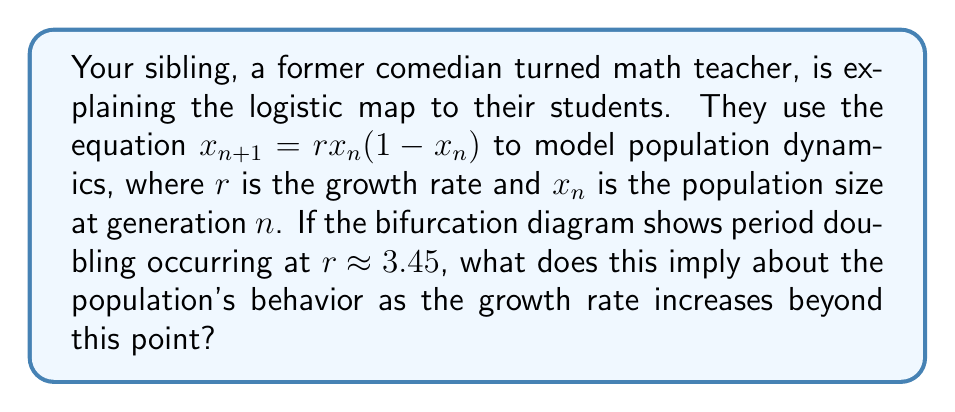What is the answer to this math problem? Let's break this down step-by-step:

1) The logistic map $x_{n+1} = rx_n(1-x_n)$ is a simple model for population growth, where:
   - $x_n$ represents the population size at generation $n$ (normalized between 0 and 1)
   - $r$ is the growth rate parameter

2) The bifurcation diagram shows how the long-term behavior of the system changes as $r$ increases:
   - For $r < 3$, the population stabilizes at a single fixed point
   - At $r \approx 3$, the system undergoes its first period-doubling bifurcation

3) The question states that period doubling occurs at $r \approx 3.45$. This means:
   - The system has already undergone its first bifurcation
   - At $r \approx 3.45$, the system transitions from a 2-cycle to a 4-cycle

4) As $r$ increases beyond 3.45:
   - More period-doubling bifurcations occur at shorter intervals
   - This leads to cycles of 8, 16, 32, and so on
   - Eventually, this cascade of bifurcations leads to chaos

5) In terms of population dynamics, this implies:
   - The population will oscillate between more and more values
   - The system becomes increasingly sensitive to initial conditions
   - Long-term prediction of exact population sizes becomes impossible

6) This phenomenon is known as the "period-doubling route to chaos"

Therefore, the bifurcation at $r \approx 3.45$ marks the beginning of a transition from simple periodic behavior to increasingly complex oscillations, ultimately leading to chaotic dynamics in the population.
Answer: Transition from periodic to chaotic population dynamics 